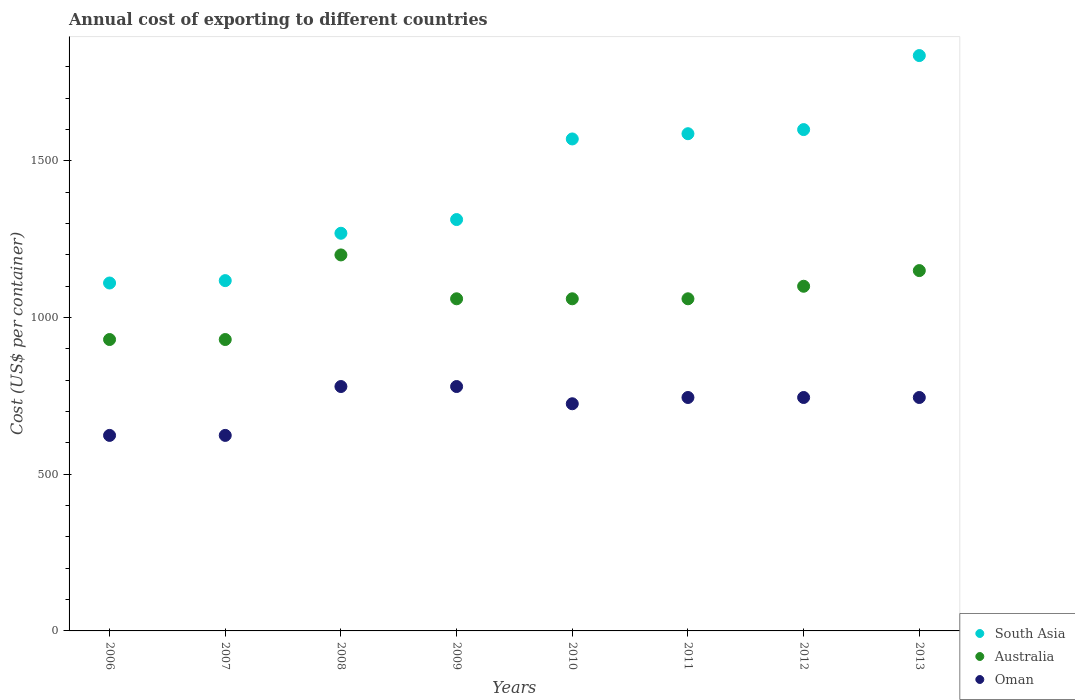What is the total annual cost of exporting in South Asia in 2007?
Your answer should be very brief. 1118. Across all years, what is the maximum total annual cost of exporting in Australia?
Your response must be concise. 1200. Across all years, what is the minimum total annual cost of exporting in Australia?
Your answer should be very brief. 930. In which year was the total annual cost of exporting in South Asia maximum?
Your answer should be compact. 2013. What is the total total annual cost of exporting in Oman in the graph?
Give a very brief answer. 5768. What is the difference between the total annual cost of exporting in South Asia in 2008 and that in 2009?
Provide a succinct answer. -43.75. What is the difference between the total annual cost of exporting in South Asia in 2007 and the total annual cost of exporting in Oman in 2009?
Make the answer very short. 338. What is the average total annual cost of exporting in Oman per year?
Offer a terse response. 721. In the year 2007, what is the difference between the total annual cost of exporting in Australia and total annual cost of exporting in South Asia?
Provide a succinct answer. -188. In how many years, is the total annual cost of exporting in Australia greater than 1500 US$?
Provide a succinct answer. 0. What is the ratio of the total annual cost of exporting in South Asia in 2008 to that in 2013?
Offer a terse response. 0.69. Is the total annual cost of exporting in Australia in 2006 less than that in 2013?
Offer a very short reply. Yes. Is the difference between the total annual cost of exporting in Australia in 2008 and 2010 greater than the difference between the total annual cost of exporting in South Asia in 2008 and 2010?
Provide a succinct answer. Yes. What is the difference between the highest and the second highest total annual cost of exporting in South Asia?
Offer a terse response. 236.25. What is the difference between the highest and the lowest total annual cost of exporting in South Asia?
Make the answer very short. 725.88. Is it the case that in every year, the sum of the total annual cost of exporting in Australia and total annual cost of exporting in South Asia  is greater than the total annual cost of exporting in Oman?
Offer a very short reply. Yes. Does the total annual cost of exporting in Australia monotonically increase over the years?
Offer a terse response. No. Is the total annual cost of exporting in Oman strictly greater than the total annual cost of exporting in Australia over the years?
Offer a very short reply. No. How many dotlines are there?
Offer a terse response. 3. Are the values on the major ticks of Y-axis written in scientific E-notation?
Offer a terse response. No. Does the graph contain any zero values?
Your answer should be very brief. No. What is the title of the graph?
Provide a succinct answer. Annual cost of exporting to different countries. What is the label or title of the X-axis?
Give a very brief answer. Years. What is the label or title of the Y-axis?
Make the answer very short. Cost (US$ per container). What is the Cost (US$ per container) in South Asia in 2006?
Your answer should be very brief. 1110.38. What is the Cost (US$ per container) of Australia in 2006?
Give a very brief answer. 930. What is the Cost (US$ per container) of Oman in 2006?
Keep it short and to the point. 624. What is the Cost (US$ per container) in South Asia in 2007?
Ensure brevity in your answer.  1118. What is the Cost (US$ per container) of Australia in 2007?
Provide a succinct answer. 930. What is the Cost (US$ per container) in Oman in 2007?
Make the answer very short. 624. What is the Cost (US$ per container) of South Asia in 2008?
Offer a very short reply. 1269.12. What is the Cost (US$ per container) in Australia in 2008?
Give a very brief answer. 1200. What is the Cost (US$ per container) of Oman in 2008?
Ensure brevity in your answer.  780. What is the Cost (US$ per container) in South Asia in 2009?
Provide a short and direct response. 1312.88. What is the Cost (US$ per container) in Australia in 2009?
Your answer should be very brief. 1060. What is the Cost (US$ per container) of Oman in 2009?
Keep it short and to the point. 780. What is the Cost (US$ per container) in South Asia in 2010?
Provide a short and direct response. 1570.12. What is the Cost (US$ per container) of Australia in 2010?
Your answer should be compact. 1060. What is the Cost (US$ per container) of Oman in 2010?
Your answer should be very brief. 725. What is the Cost (US$ per container) of South Asia in 2011?
Ensure brevity in your answer.  1586.88. What is the Cost (US$ per container) in Australia in 2011?
Offer a very short reply. 1060. What is the Cost (US$ per container) in Oman in 2011?
Your response must be concise. 745. What is the Cost (US$ per container) in South Asia in 2012?
Your answer should be compact. 1600. What is the Cost (US$ per container) of Australia in 2012?
Ensure brevity in your answer.  1100. What is the Cost (US$ per container) of Oman in 2012?
Offer a very short reply. 745. What is the Cost (US$ per container) in South Asia in 2013?
Your response must be concise. 1836.25. What is the Cost (US$ per container) in Australia in 2013?
Your answer should be compact. 1150. What is the Cost (US$ per container) of Oman in 2013?
Your answer should be very brief. 745. Across all years, what is the maximum Cost (US$ per container) in South Asia?
Offer a terse response. 1836.25. Across all years, what is the maximum Cost (US$ per container) in Australia?
Provide a succinct answer. 1200. Across all years, what is the maximum Cost (US$ per container) of Oman?
Offer a very short reply. 780. Across all years, what is the minimum Cost (US$ per container) in South Asia?
Your answer should be very brief. 1110.38. Across all years, what is the minimum Cost (US$ per container) of Australia?
Ensure brevity in your answer.  930. Across all years, what is the minimum Cost (US$ per container) of Oman?
Your answer should be very brief. 624. What is the total Cost (US$ per container) in South Asia in the graph?
Offer a very short reply. 1.14e+04. What is the total Cost (US$ per container) of Australia in the graph?
Offer a very short reply. 8490. What is the total Cost (US$ per container) in Oman in the graph?
Offer a terse response. 5768. What is the difference between the Cost (US$ per container) in South Asia in 2006 and that in 2007?
Give a very brief answer. -7.62. What is the difference between the Cost (US$ per container) in South Asia in 2006 and that in 2008?
Give a very brief answer. -158.75. What is the difference between the Cost (US$ per container) in Australia in 2006 and that in 2008?
Your answer should be compact. -270. What is the difference between the Cost (US$ per container) of Oman in 2006 and that in 2008?
Your response must be concise. -156. What is the difference between the Cost (US$ per container) in South Asia in 2006 and that in 2009?
Provide a short and direct response. -202.5. What is the difference between the Cost (US$ per container) of Australia in 2006 and that in 2009?
Your answer should be compact. -130. What is the difference between the Cost (US$ per container) of Oman in 2006 and that in 2009?
Provide a succinct answer. -156. What is the difference between the Cost (US$ per container) of South Asia in 2006 and that in 2010?
Provide a succinct answer. -459.75. What is the difference between the Cost (US$ per container) in Australia in 2006 and that in 2010?
Give a very brief answer. -130. What is the difference between the Cost (US$ per container) in Oman in 2006 and that in 2010?
Offer a terse response. -101. What is the difference between the Cost (US$ per container) in South Asia in 2006 and that in 2011?
Give a very brief answer. -476.5. What is the difference between the Cost (US$ per container) in Australia in 2006 and that in 2011?
Keep it short and to the point. -130. What is the difference between the Cost (US$ per container) of Oman in 2006 and that in 2011?
Make the answer very short. -121. What is the difference between the Cost (US$ per container) in South Asia in 2006 and that in 2012?
Keep it short and to the point. -489.62. What is the difference between the Cost (US$ per container) in Australia in 2006 and that in 2012?
Your answer should be compact. -170. What is the difference between the Cost (US$ per container) of Oman in 2006 and that in 2012?
Your answer should be compact. -121. What is the difference between the Cost (US$ per container) in South Asia in 2006 and that in 2013?
Provide a succinct answer. -725.88. What is the difference between the Cost (US$ per container) of Australia in 2006 and that in 2013?
Provide a short and direct response. -220. What is the difference between the Cost (US$ per container) in Oman in 2006 and that in 2013?
Your response must be concise. -121. What is the difference between the Cost (US$ per container) of South Asia in 2007 and that in 2008?
Offer a terse response. -151.12. What is the difference between the Cost (US$ per container) of Australia in 2007 and that in 2008?
Offer a terse response. -270. What is the difference between the Cost (US$ per container) in Oman in 2007 and that in 2008?
Keep it short and to the point. -156. What is the difference between the Cost (US$ per container) of South Asia in 2007 and that in 2009?
Make the answer very short. -194.88. What is the difference between the Cost (US$ per container) of Australia in 2007 and that in 2009?
Keep it short and to the point. -130. What is the difference between the Cost (US$ per container) of Oman in 2007 and that in 2009?
Give a very brief answer. -156. What is the difference between the Cost (US$ per container) of South Asia in 2007 and that in 2010?
Your response must be concise. -452.12. What is the difference between the Cost (US$ per container) in Australia in 2007 and that in 2010?
Offer a very short reply. -130. What is the difference between the Cost (US$ per container) in Oman in 2007 and that in 2010?
Offer a very short reply. -101. What is the difference between the Cost (US$ per container) of South Asia in 2007 and that in 2011?
Offer a terse response. -468.88. What is the difference between the Cost (US$ per container) in Australia in 2007 and that in 2011?
Keep it short and to the point. -130. What is the difference between the Cost (US$ per container) in Oman in 2007 and that in 2011?
Ensure brevity in your answer.  -121. What is the difference between the Cost (US$ per container) of South Asia in 2007 and that in 2012?
Provide a succinct answer. -482. What is the difference between the Cost (US$ per container) in Australia in 2007 and that in 2012?
Your answer should be compact. -170. What is the difference between the Cost (US$ per container) in Oman in 2007 and that in 2012?
Offer a terse response. -121. What is the difference between the Cost (US$ per container) in South Asia in 2007 and that in 2013?
Your answer should be very brief. -718.25. What is the difference between the Cost (US$ per container) in Australia in 2007 and that in 2013?
Keep it short and to the point. -220. What is the difference between the Cost (US$ per container) in Oman in 2007 and that in 2013?
Offer a terse response. -121. What is the difference between the Cost (US$ per container) of South Asia in 2008 and that in 2009?
Your response must be concise. -43.75. What is the difference between the Cost (US$ per container) in Australia in 2008 and that in 2009?
Keep it short and to the point. 140. What is the difference between the Cost (US$ per container) in South Asia in 2008 and that in 2010?
Give a very brief answer. -301. What is the difference between the Cost (US$ per container) of Australia in 2008 and that in 2010?
Your answer should be very brief. 140. What is the difference between the Cost (US$ per container) of South Asia in 2008 and that in 2011?
Offer a terse response. -317.75. What is the difference between the Cost (US$ per container) in Australia in 2008 and that in 2011?
Your answer should be very brief. 140. What is the difference between the Cost (US$ per container) in Oman in 2008 and that in 2011?
Ensure brevity in your answer.  35. What is the difference between the Cost (US$ per container) in South Asia in 2008 and that in 2012?
Make the answer very short. -330.88. What is the difference between the Cost (US$ per container) in Australia in 2008 and that in 2012?
Your response must be concise. 100. What is the difference between the Cost (US$ per container) of South Asia in 2008 and that in 2013?
Ensure brevity in your answer.  -567.12. What is the difference between the Cost (US$ per container) of Australia in 2008 and that in 2013?
Your answer should be compact. 50. What is the difference between the Cost (US$ per container) in South Asia in 2009 and that in 2010?
Keep it short and to the point. -257.25. What is the difference between the Cost (US$ per container) of Australia in 2009 and that in 2010?
Provide a succinct answer. 0. What is the difference between the Cost (US$ per container) of Oman in 2009 and that in 2010?
Give a very brief answer. 55. What is the difference between the Cost (US$ per container) in South Asia in 2009 and that in 2011?
Your response must be concise. -274. What is the difference between the Cost (US$ per container) in South Asia in 2009 and that in 2012?
Offer a terse response. -287.12. What is the difference between the Cost (US$ per container) in South Asia in 2009 and that in 2013?
Ensure brevity in your answer.  -523.38. What is the difference between the Cost (US$ per container) in Australia in 2009 and that in 2013?
Make the answer very short. -90. What is the difference between the Cost (US$ per container) in Oman in 2009 and that in 2013?
Offer a terse response. 35. What is the difference between the Cost (US$ per container) of South Asia in 2010 and that in 2011?
Provide a short and direct response. -16.75. What is the difference between the Cost (US$ per container) of Australia in 2010 and that in 2011?
Ensure brevity in your answer.  0. What is the difference between the Cost (US$ per container) in South Asia in 2010 and that in 2012?
Your response must be concise. -29.88. What is the difference between the Cost (US$ per container) of Australia in 2010 and that in 2012?
Make the answer very short. -40. What is the difference between the Cost (US$ per container) of Oman in 2010 and that in 2012?
Keep it short and to the point. -20. What is the difference between the Cost (US$ per container) of South Asia in 2010 and that in 2013?
Offer a very short reply. -266.12. What is the difference between the Cost (US$ per container) of Australia in 2010 and that in 2013?
Your answer should be compact. -90. What is the difference between the Cost (US$ per container) of South Asia in 2011 and that in 2012?
Offer a very short reply. -13.12. What is the difference between the Cost (US$ per container) of South Asia in 2011 and that in 2013?
Provide a short and direct response. -249.38. What is the difference between the Cost (US$ per container) in Australia in 2011 and that in 2013?
Offer a terse response. -90. What is the difference between the Cost (US$ per container) of South Asia in 2012 and that in 2013?
Offer a very short reply. -236.25. What is the difference between the Cost (US$ per container) in South Asia in 2006 and the Cost (US$ per container) in Australia in 2007?
Keep it short and to the point. 180.38. What is the difference between the Cost (US$ per container) in South Asia in 2006 and the Cost (US$ per container) in Oman in 2007?
Your answer should be compact. 486.38. What is the difference between the Cost (US$ per container) in Australia in 2006 and the Cost (US$ per container) in Oman in 2007?
Your answer should be very brief. 306. What is the difference between the Cost (US$ per container) of South Asia in 2006 and the Cost (US$ per container) of Australia in 2008?
Your response must be concise. -89.62. What is the difference between the Cost (US$ per container) of South Asia in 2006 and the Cost (US$ per container) of Oman in 2008?
Provide a succinct answer. 330.38. What is the difference between the Cost (US$ per container) in Australia in 2006 and the Cost (US$ per container) in Oman in 2008?
Make the answer very short. 150. What is the difference between the Cost (US$ per container) of South Asia in 2006 and the Cost (US$ per container) of Australia in 2009?
Offer a very short reply. 50.38. What is the difference between the Cost (US$ per container) in South Asia in 2006 and the Cost (US$ per container) in Oman in 2009?
Your answer should be compact. 330.38. What is the difference between the Cost (US$ per container) of Australia in 2006 and the Cost (US$ per container) of Oman in 2009?
Your response must be concise. 150. What is the difference between the Cost (US$ per container) in South Asia in 2006 and the Cost (US$ per container) in Australia in 2010?
Your answer should be very brief. 50.38. What is the difference between the Cost (US$ per container) of South Asia in 2006 and the Cost (US$ per container) of Oman in 2010?
Your answer should be very brief. 385.38. What is the difference between the Cost (US$ per container) in Australia in 2006 and the Cost (US$ per container) in Oman in 2010?
Offer a terse response. 205. What is the difference between the Cost (US$ per container) of South Asia in 2006 and the Cost (US$ per container) of Australia in 2011?
Provide a short and direct response. 50.38. What is the difference between the Cost (US$ per container) of South Asia in 2006 and the Cost (US$ per container) of Oman in 2011?
Your response must be concise. 365.38. What is the difference between the Cost (US$ per container) in Australia in 2006 and the Cost (US$ per container) in Oman in 2011?
Provide a succinct answer. 185. What is the difference between the Cost (US$ per container) of South Asia in 2006 and the Cost (US$ per container) of Australia in 2012?
Offer a terse response. 10.38. What is the difference between the Cost (US$ per container) in South Asia in 2006 and the Cost (US$ per container) in Oman in 2012?
Your response must be concise. 365.38. What is the difference between the Cost (US$ per container) of Australia in 2006 and the Cost (US$ per container) of Oman in 2012?
Give a very brief answer. 185. What is the difference between the Cost (US$ per container) of South Asia in 2006 and the Cost (US$ per container) of Australia in 2013?
Your response must be concise. -39.62. What is the difference between the Cost (US$ per container) of South Asia in 2006 and the Cost (US$ per container) of Oman in 2013?
Offer a very short reply. 365.38. What is the difference between the Cost (US$ per container) of Australia in 2006 and the Cost (US$ per container) of Oman in 2013?
Your answer should be very brief. 185. What is the difference between the Cost (US$ per container) of South Asia in 2007 and the Cost (US$ per container) of Australia in 2008?
Provide a succinct answer. -82. What is the difference between the Cost (US$ per container) of South Asia in 2007 and the Cost (US$ per container) of Oman in 2008?
Ensure brevity in your answer.  338. What is the difference between the Cost (US$ per container) in Australia in 2007 and the Cost (US$ per container) in Oman in 2008?
Your answer should be compact. 150. What is the difference between the Cost (US$ per container) of South Asia in 2007 and the Cost (US$ per container) of Oman in 2009?
Offer a very short reply. 338. What is the difference between the Cost (US$ per container) in Australia in 2007 and the Cost (US$ per container) in Oman in 2009?
Give a very brief answer. 150. What is the difference between the Cost (US$ per container) in South Asia in 2007 and the Cost (US$ per container) in Australia in 2010?
Your answer should be compact. 58. What is the difference between the Cost (US$ per container) of South Asia in 2007 and the Cost (US$ per container) of Oman in 2010?
Offer a terse response. 393. What is the difference between the Cost (US$ per container) in Australia in 2007 and the Cost (US$ per container) in Oman in 2010?
Keep it short and to the point. 205. What is the difference between the Cost (US$ per container) in South Asia in 2007 and the Cost (US$ per container) in Australia in 2011?
Provide a short and direct response. 58. What is the difference between the Cost (US$ per container) in South Asia in 2007 and the Cost (US$ per container) in Oman in 2011?
Your answer should be very brief. 373. What is the difference between the Cost (US$ per container) in Australia in 2007 and the Cost (US$ per container) in Oman in 2011?
Your answer should be compact. 185. What is the difference between the Cost (US$ per container) of South Asia in 2007 and the Cost (US$ per container) of Australia in 2012?
Offer a terse response. 18. What is the difference between the Cost (US$ per container) of South Asia in 2007 and the Cost (US$ per container) of Oman in 2012?
Give a very brief answer. 373. What is the difference between the Cost (US$ per container) of Australia in 2007 and the Cost (US$ per container) of Oman in 2012?
Provide a succinct answer. 185. What is the difference between the Cost (US$ per container) in South Asia in 2007 and the Cost (US$ per container) in Australia in 2013?
Offer a very short reply. -32. What is the difference between the Cost (US$ per container) in South Asia in 2007 and the Cost (US$ per container) in Oman in 2013?
Offer a very short reply. 373. What is the difference between the Cost (US$ per container) of Australia in 2007 and the Cost (US$ per container) of Oman in 2013?
Keep it short and to the point. 185. What is the difference between the Cost (US$ per container) in South Asia in 2008 and the Cost (US$ per container) in Australia in 2009?
Provide a succinct answer. 209.12. What is the difference between the Cost (US$ per container) in South Asia in 2008 and the Cost (US$ per container) in Oman in 2009?
Provide a short and direct response. 489.12. What is the difference between the Cost (US$ per container) in Australia in 2008 and the Cost (US$ per container) in Oman in 2009?
Keep it short and to the point. 420. What is the difference between the Cost (US$ per container) of South Asia in 2008 and the Cost (US$ per container) of Australia in 2010?
Ensure brevity in your answer.  209.12. What is the difference between the Cost (US$ per container) in South Asia in 2008 and the Cost (US$ per container) in Oman in 2010?
Your answer should be compact. 544.12. What is the difference between the Cost (US$ per container) of Australia in 2008 and the Cost (US$ per container) of Oman in 2010?
Provide a short and direct response. 475. What is the difference between the Cost (US$ per container) of South Asia in 2008 and the Cost (US$ per container) of Australia in 2011?
Ensure brevity in your answer.  209.12. What is the difference between the Cost (US$ per container) of South Asia in 2008 and the Cost (US$ per container) of Oman in 2011?
Ensure brevity in your answer.  524.12. What is the difference between the Cost (US$ per container) in Australia in 2008 and the Cost (US$ per container) in Oman in 2011?
Your answer should be very brief. 455. What is the difference between the Cost (US$ per container) of South Asia in 2008 and the Cost (US$ per container) of Australia in 2012?
Keep it short and to the point. 169.12. What is the difference between the Cost (US$ per container) in South Asia in 2008 and the Cost (US$ per container) in Oman in 2012?
Offer a very short reply. 524.12. What is the difference between the Cost (US$ per container) in Australia in 2008 and the Cost (US$ per container) in Oman in 2012?
Provide a short and direct response. 455. What is the difference between the Cost (US$ per container) in South Asia in 2008 and the Cost (US$ per container) in Australia in 2013?
Provide a succinct answer. 119.12. What is the difference between the Cost (US$ per container) in South Asia in 2008 and the Cost (US$ per container) in Oman in 2013?
Your answer should be very brief. 524.12. What is the difference between the Cost (US$ per container) of Australia in 2008 and the Cost (US$ per container) of Oman in 2013?
Give a very brief answer. 455. What is the difference between the Cost (US$ per container) of South Asia in 2009 and the Cost (US$ per container) of Australia in 2010?
Ensure brevity in your answer.  252.88. What is the difference between the Cost (US$ per container) in South Asia in 2009 and the Cost (US$ per container) in Oman in 2010?
Your answer should be very brief. 587.88. What is the difference between the Cost (US$ per container) of Australia in 2009 and the Cost (US$ per container) of Oman in 2010?
Ensure brevity in your answer.  335. What is the difference between the Cost (US$ per container) in South Asia in 2009 and the Cost (US$ per container) in Australia in 2011?
Offer a very short reply. 252.88. What is the difference between the Cost (US$ per container) of South Asia in 2009 and the Cost (US$ per container) of Oman in 2011?
Provide a succinct answer. 567.88. What is the difference between the Cost (US$ per container) in Australia in 2009 and the Cost (US$ per container) in Oman in 2011?
Provide a short and direct response. 315. What is the difference between the Cost (US$ per container) in South Asia in 2009 and the Cost (US$ per container) in Australia in 2012?
Give a very brief answer. 212.88. What is the difference between the Cost (US$ per container) in South Asia in 2009 and the Cost (US$ per container) in Oman in 2012?
Keep it short and to the point. 567.88. What is the difference between the Cost (US$ per container) of Australia in 2009 and the Cost (US$ per container) of Oman in 2012?
Ensure brevity in your answer.  315. What is the difference between the Cost (US$ per container) in South Asia in 2009 and the Cost (US$ per container) in Australia in 2013?
Offer a very short reply. 162.88. What is the difference between the Cost (US$ per container) in South Asia in 2009 and the Cost (US$ per container) in Oman in 2013?
Your answer should be very brief. 567.88. What is the difference between the Cost (US$ per container) in Australia in 2009 and the Cost (US$ per container) in Oman in 2013?
Give a very brief answer. 315. What is the difference between the Cost (US$ per container) in South Asia in 2010 and the Cost (US$ per container) in Australia in 2011?
Your response must be concise. 510.12. What is the difference between the Cost (US$ per container) of South Asia in 2010 and the Cost (US$ per container) of Oman in 2011?
Keep it short and to the point. 825.12. What is the difference between the Cost (US$ per container) of Australia in 2010 and the Cost (US$ per container) of Oman in 2011?
Offer a terse response. 315. What is the difference between the Cost (US$ per container) in South Asia in 2010 and the Cost (US$ per container) in Australia in 2012?
Provide a succinct answer. 470.12. What is the difference between the Cost (US$ per container) of South Asia in 2010 and the Cost (US$ per container) of Oman in 2012?
Ensure brevity in your answer.  825.12. What is the difference between the Cost (US$ per container) of Australia in 2010 and the Cost (US$ per container) of Oman in 2012?
Your response must be concise. 315. What is the difference between the Cost (US$ per container) in South Asia in 2010 and the Cost (US$ per container) in Australia in 2013?
Offer a terse response. 420.12. What is the difference between the Cost (US$ per container) in South Asia in 2010 and the Cost (US$ per container) in Oman in 2013?
Your answer should be very brief. 825.12. What is the difference between the Cost (US$ per container) in Australia in 2010 and the Cost (US$ per container) in Oman in 2013?
Ensure brevity in your answer.  315. What is the difference between the Cost (US$ per container) in South Asia in 2011 and the Cost (US$ per container) in Australia in 2012?
Your answer should be very brief. 486.88. What is the difference between the Cost (US$ per container) in South Asia in 2011 and the Cost (US$ per container) in Oman in 2012?
Offer a very short reply. 841.88. What is the difference between the Cost (US$ per container) of Australia in 2011 and the Cost (US$ per container) of Oman in 2012?
Offer a very short reply. 315. What is the difference between the Cost (US$ per container) in South Asia in 2011 and the Cost (US$ per container) in Australia in 2013?
Keep it short and to the point. 436.88. What is the difference between the Cost (US$ per container) of South Asia in 2011 and the Cost (US$ per container) of Oman in 2013?
Ensure brevity in your answer.  841.88. What is the difference between the Cost (US$ per container) in Australia in 2011 and the Cost (US$ per container) in Oman in 2013?
Provide a succinct answer. 315. What is the difference between the Cost (US$ per container) in South Asia in 2012 and the Cost (US$ per container) in Australia in 2013?
Ensure brevity in your answer.  450. What is the difference between the Cost (US$ per container) in South Asia in 2012 and the Cost (US$ per container) in Oman in 2013?
Your answer should be very brief. 855. What is the difference between the Cost (US$ per container) of Australia in 2012 and the Cost (US$ per container) of Oman in 2013?
Make the answer very short. 355. What is the average Cost (US$ per container) in South Asia per year?
Give a very brief answer. 1425.45. What is the average Cost (US$ per container) of Australia per year?
Offer a terse response. 1061.25. What is the average Cost (US$ per container) in Oman per year?
Give a very brief answer. 721. In the year 2006, what is the difference between the Cost (US$ per container) in South Asia and Cost (US$ per container) in Australia?
Your answer should be very brief. 180.38. In the year 2006, what is the difference between the Cost (US$ per container) in South Asia and Cost (US$ per container) in Oman?
Your response must be concise. 486.38. In the year 2006, what is the difference between the Cost (US$ per container) of Australia and Cost (US$ per container) of Oman?
Offer a terse response. 306. In the year 2007, what is the difference between the Cost (US$ per container) of South Asia and Cost (US$ per container) of Australia?
Your answer should be very brief. 188. In the year 2007, what is the difference between the Cost (US$ per container) of South Asia and Cost (US$ per container) of Oman?
Your response must be concise. 494. In the year 2007, what is the difference between the Cost (US$ per container) in Australia and Cost (US$ per container) in Oman?
Your answer should be very brief. 306. In the year 2008, what is the difference between the Cost (US$ per container) in South Asia and Cost (US$ per container) in Australia?
Make the answer very short. 69.12. In the year 2008, what is the difference between the Cost (US$ per container) of South Asia and Cost (US$ per container) of Oman?
Ensure brevity in your answer.  489.12. In the year 2008, what is the difference between the Cost (US$ per container) in Australia and Cost (US$ per container) in Oman?
Ensure brevity in your answer.  420. In the year 2009, what is the difference between the Cost (US$ per container) of South Asia and Cost (US$ per container) of Australia?
Your answer should be compact. 252.88. In the year 2009, what is the difference between the Cost (US$ per container) in South Asia and Cost (US$ per container) in Oman?
Your answer should be very brief. 532.88. In the year 2009, what is the difference between the Cost (US$ per container) in Australia and Cost (US$ per container) in Oman?
Offer a very short reply. 280. In the year 2010, what is the difference between the Cost (US$ per container) in South Asia and Cost (US$ per container) in Australia?
Your answer should be compact. 510.12. In the year 2010, what is the difference between the Cost (US$ per container) in South Asia and Cost (US$ per container) in Oman?
Your answer should be very brief. 845.12. In the year 2010, what is the difference between the Cost (US$ per container) of Australia and Cost (US$ per container) of Oman?
Offer a terse response. 335. In the year 2011, what is the difference between the Cost (US$ per container) of South Asia and Cost (US$ per container) of Australia?
Provide a succinct answer. 526.88. In the year 2011, what is the difference between the Cost (US$ per container) of South Asia and Cost (US$ per container) of Oman?
Your response must be concise. 841.88. In the year 2011, what is the difference between the Cost (US$ per container) in Australia and Cost (US$ per container) in Oman?
Your response must be concise. 315. In the year 2012, what is the difference between the Cost (US$ per container) in South Asia and Cost (US$ per container) in Australia?
Your answer should be compact. 500. In the year 2012, what is the difference between the Cost (US$ per container) of South Asia and Cost (US$ per container) of Oman?
Your answer should be compact. 855. In the year 2012, what is the difference between the Cost (US$ per container) of Australia and Cost (US$ per container) of Oman?
Keep it short and to the point. 355. In the year 2013, what is the difference between the Cost (US$ per container) of South Asia and Cost (US$ per container) of Australia?
Make the answer very short. 686.25. In the year 2013, what is the difference between the Cost (US$ per container) of South Asia and Cost (US$ per container) of Oman?
Give a very brief answer. 1091.25. In the year 2013, what is the difference between the Cost (US$ per container) in Australia and Cost (US$ per container) in Oman?
Your response must be concise. 405. What is the ratio of the Cost (US$ per container) of South Asia in 2006 to that in 2007?
Provide a short and direct response. 0.99. What is the ratio of the Cost (US$ per container) of Australia in 2006 to that in 2007?
Offer a very short reply. 1. What is the ratio of the Cost (US$ per container) of Oman in 2006 to that in 2007?
Give a very brief answer. 1. What is the ratio of the Cost (US$ per container) in South Asia in 2006 to that in 2008?
Your answer should be very brief. 0.87. What is the ratio of the Cost (US$ per container) in Australia in 2006 to that in 2008?
Make the answer very short. 0.78. What is the ratio of the Cost (US$ per container) in Oman in 2006 to that in 2008?
Your answer should be very brief. 0.8. What is the ratio of the Cost (US$ per container) of South Asia in 2006 to that in 2009?
Offer a terse response. 0.85. What is the ratio of the Cost (US$ per container) in Australia in 2006 to that in 2009?
Keep it short and to the point. 0.88. What is the ratio of the Cost (US$ per container) in South Asia in 2006 to that in 2010?
Give a very brief answer. 0.71. What is the ratio of the Cost (US$ per container) in Australia in 2006 to that in 2010?
Keep it short and to the point. 0.88. What is the ratio of the Cost (US$ per container) in Oman in 2006 to that in 2010?
Offer a very short reply. 0.86. What is the ratio of the Cost (US$ per container) in South Asia in 2006 to that in 2011?
Your answer should be very brief. 0.7. What is the ratio of the Cost (US$ per container) in Australia in 2006 to that in 2011?
Your answer should be compact. 0.88. What is the ratio of the Cost (US$ per container) of Oman in 2006 to that in 2011?
Make the answer very short. 0.84. What is the ratio of the Cost (US$ per container) in South Asia in 2006 to that in 2012?
Give a very brief answer. 0.69. What is the ratio of the Cost (US$ per container) of Australia in 2006 to that in 2012?
Provide a short and direct response. 0.85. What is the ratio of the Cost (US$ per container) of Oman in 2006 to that in 2012?
Provide a succinct answer. 0.84. What is the ratio of the Cost (US$ per container) of South Asia in 2006 to that in 2013?
Your response must be concise. 0.6. What is the ratio of the Cost (US$ per container) of Australia in 2006 to that in 2013?
Give a very brief answer. 0.81. What is the ratio of the Cost (US$ per container) of Oman in 2006 to that in 2013?
Offer a very short reply. 0.84. What is the ratio of the Cost (US$ per container) of South Asia in 2007 to that in 2008?
Ensure brevity in your answer.  0.88. What is the ratio of the Cost (US$ per container) in Australia in 2007 to that in 2008?
Provide a short and direct response. 0.78. What is the ratio of the Cost (US$ per container) of Oman in 2007 to that in 2008?
Your response must be concise. 0.8. What is the ratio of the Cost (US$ per container) of South Asia in 2007 to that in 2009?
Provide a short and direct response. 0.85. What is the ratio of the Cost (US$ per container) of Australia in 2007 to that in 2009?
Keep it short and to the point. 0.88. What is the ratio of the Cost (US$ per container) in South Asia in 2007 to that in 2010?
Your answer should be compact. 0.71. What is the ratio of the Cost (US$ per container) in Australia in 2007 to that in 2010?
Your answer should be compact. 0.88. What is the ratio of the Cost (US$ per container) in Oman in 2007 to that in 2010?
Your response must be concise. 0.86. What is the ratio of the Cost (US$ per container) of South Asia in 2007 to that in 2011?
Make the answer very short. 0.7. What is the ratio of the Cost (US$ per container) in Australia in 2007 to that in 2011?
Your response must be concise. 0.88. What is the ratio of the Cost (US$ per container) in Oman in 2007 to that in 2011?
Provide a short and direct response. 0.84. What is the ratio of the Cost (US$ per container) of South Asia in 2007 to that in 2012?
Offer a terse response. 0.7. What is the ratio of the Cost (US$ per container) of Australia in 2007 to that in 2012?
Ensure brevity in your answer.  0.85. What is the ratio of the Cost (US$ per container) in Oman in 2007 to that in 2012?
Provide a succinct answer. 0.84. What is the ratio of the Cost (US$ per container) in South Asia in 2007 to that in 2013?
Your answer should be compact. 0.61. What is the ratio of the Cost (US$ per container) of Australia in 2007 to that in 2013?
Provide a short and direct response. 0.81. What is the ratio of the Cost (US$ per container) of Oman in 2007 to that in 2013?
Keep it short and to the point. 0.84. What is the ratio of the Cost (US$ per container) in South Asia in 2008 to that in 2009?
Offer a terse response. 0.97. What is the ratio of the Cost (US$ per container) of Australia in 2008 to that in 2009?
Offer a terse response. 1.13. What is the ratio of the Cost (US$ per container) of South Asia in 2008 to that in 2010?
Make the answer very short. 0.81. What is the ratio of the Cost (US$ per container) of Australia in 2008 to that in 2010?
Your response must be concise. 1.13. What is the ratio of the Cost (US$ per container) in Oman in 2008 to that in 2010?
Provide a succinct answer. 1.08. What is the ratio of the Cost (US$ per container) in South Asia in 2008 to that in 2011?
Keep it short and to the point. 0.8. What is the ratio of the Cost (US$ per container) of Australia in 2008 to that in 2011?
Provide a short and direct response. 1.13. What is the ratio of the Cost (US$ per container) of Oman in 2008 to that in 2011?
Keep it short and to the point. 1.05. What is the ratio of the Cost (US$ per container) of South Asia in 2008 to that in 2012?
Keep it short and to the point. 0.79. What is the ratio of the Cost (US$ per container) in Australia in 2008 to that in 2012?
Provide a succinct answer. 1.09. What is the ratio of the Cost (US$ per container) in Oman in 2008 to that in 2012?
Your response must be concise. 1.05. What is the ratio of the Cost (US$ per container) in South Asia in 2008 to that in 2013?
Keep it short and to the point. 0.69. What is the ratio of the Cost (US$ per container) in Australia in 2008 to that in 2013?
Your response must be concise. 1.04. What is the ratio of the Cost (US$ per container) of Oman in 2008 to that in 2013?
Provide a short and direct response. 1.05. What is the ratio of the Cost (US$ per container) of South Asia in 2009 to that in 2010?
Your answer should be very brief. 0.84. What is the ratio of the Cost (US$ per container) of Australia in 2009 to that in 2010?
Provide a succinct answer. 1. What is the ratio of the Cost (US$ per container) of Oman in 2009 to that in 2010?
Provide a short and direct response. 1.08. What is the ratio of the Cost (US$ per container) in South Asia in 2009 to that in 2011?
Offer a very short reply. 0.83. What is the ratio of the Cost (US$ per container) of Oman in 2009 to that in 2011?
Provide a succinct answer. 1.05. What is the ratio of the Cost (US$ per container) in South Asia in 2009 to that in 2012?
Ensure brevity in your answer.  0.82. What is the ratio of the Cost (US$ per container) in Australia in 2009 to that in 2012?
Your response must be concise. 0.96. What is the ratio of the Cost (US$ per container) of Oman in 2009 to that in 2012?
Offer a very short reply. 1.05. What is the ratio of the Cost (US$ per container) in South Asia in 2009 to that in 2013?
Ensure brevity in your answer.  0.71. What is the ratio of the Cost (US$ per container) in Australia in 2009 to that in 2013?
Your response must be concise. 0.92. What is the ratio of the Cost (US$ per container) in Oman in 2009 to that in 2013?
Keep it short and to the point. 1.05. What is the ratio of the Cost (US$ per container) of Oman in 2010 to that in 2011?
Provide a succinct answer. 0.97. What is the ratio of the Cost (US$ per container) in South Asia in 2010 to that in 2012?
Offer a very short reply. 0.98. What is the ratio of the Cost (US$ per container) in Australia in 2010 to that in 2012?
Your answer should be very brief. 0.96. What is the ratio of the Cost (US$ per container) of Oman in 2010 to that in 2012?
Your answer should be very brief. 0.97. What is the ratio of the Cost (US$ per container) of South Asia in 2010 to that in 2013?
Offer a very short reply. 0.86. What is the ratio of the Cost (US$ per container) of Australia in 2010 to that in 2013?
Keep it short and to the point. 0.92. What is the ratio of the Cost (US$ per container) of Oman in 2010 to that in 2013?
Make the answer very short. 0.97. What is the ratio of the Cost (US$ per container) in South Asia in 2011 to that in 2012?
Provide a succinct answer. 0.99. What is the ratio of the Cost (US$ per container) in Australia in 2011 to that in 2012?
Ensure brevity in your answer.  0.96. What is the ratio of the Cost (US$ per container) of Oman in 2011 to that in 2012?
Offer a very short reply. 1. What is the ratio of the Cost (US$ per container) of South Asia in 2011 to that in 2013?
Your response must be concise. 0.86. What is the ratio of the Cost (US$ per container) in Australia in 2011 to that in 2013?
Your answer should be very brief. 0.92. What is the ratio of the Cost (US$ per container) in South Asia in 2012 to that in 2013?
Your answer should be compact. 0.87. What is the ratio of the Cost (US$ per container) of Australia in 2012 to that in 2013?
Offer a terse response. 0.96. What is the ratio of the Cost (US$ per container) in Oman in 2012 to that in 2013?
Offer a terse response. 1. What is the difference between the highest and the second highest Cost (US$ per container) of South Asia?
Your answer should be compact. 236.25. What is the difference between the highest and the second highest Cost (US$ per container) of Australia?
Offer a terse response. 50. What is the difference between the highest and the lowest Cost (US$ per container) in South Asia?
Your answer should be compact. 725.88. What is the difference between the highest and the lowest Cost (US$ per container) of Australia?
Provide a short and direct response. 270. What is the difference between the highest and the lowest Cost (US$ per container) of Oman?
Your response must be concise. 156. 